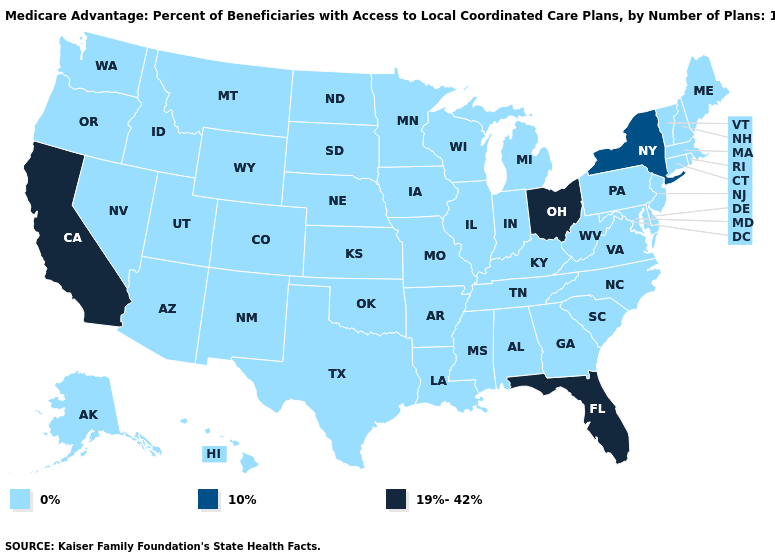Name the states that have a value in the range 19%-42%?
Concise answer only. California, Florida, Ohio. What is the lowest value in the USA?
Short answer required. 0%. Is the legend a continuous bar?
Write a very short answer. No. Name the states that have a value in the range 0%?
Concise answer only. Alaska, Alabama, Arkansas, Arizona, Colorado, Connecticut, Delaware, Georgia, Hawaii, Iowa, Idaho, Illinois, Indiana, Kansas, Kentucky, Louisiana, Massachusetts, Maryland, Maine, Michigan, Minnesota, Missouri, Mississippi, Montana, North Carolina, North Dakota, Nebraska, New Hampshire, New Jersey, New Mexico, Nevada, Oklahoma, Oregon, Pennsylvania, Rhode Island, South Carolina, South Dakota, Tennessee, Texas, Utah, Virginia, Vermont, Washington, Wisconsin, West Virginia, Wyoming. Which states have the lowest value in the USA?
Be succinct. Alaska, Alabama, Arkansas, Arizona, Colorado, Connecticut, Delaware, Georgia, Hawaii, Iowa, Idaho, Illinois, Indiana, Kansas, Kentucky, Louisiana, Massachusetts, Maryland, Maine, Michigan, Minnesota, Missouri, Mississippi, Montana, North Carolina, North Dakota, Nebraska, New Hampshire, New Jersey, New Mexico, Nevada, Oklahoma, Oregon, Pennsylvania, Rhode Island, South Carolina, South Dakota, Tennessee, Texas, Utah, Virginia, Vermont, Washington, Wisconsin, West Virginia, Wyoming. Is the legend a continuous bar?
Quick response, please. No. What is the value of Tennessee?
Short answer required. 0%. Name the states that have a value in the range 19%-42%?
Give a very brief answer. California, Florida, Ohio. Is the legend a continuous bar?
Give a very brief answer. No. Does Oklahoma have the highest value in the South?
Quick response, please. No. Among the states that border Kentucky , does Ohio have the highest value?
Write a very short answer. Yes. Does Ohio have the highest value in the MidWest?
Answer briefly. Yes. What is the value of Montana?
Write a very short answer. 0%. What is the value of Vermont?
Concise answer only. 0%. 